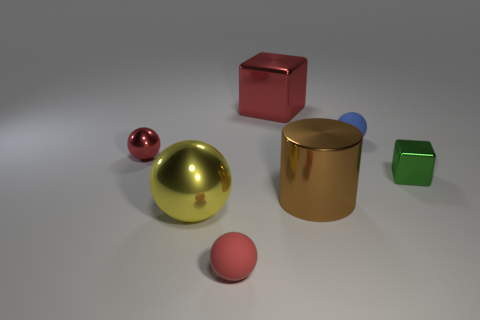Subtract all red shiny spheres. How many spheres are left? 3 Subtract all red blocks. How many red balls are left? 2 Subtract all blue balls. How many balls are left? 3 Add 1 small red things. How many objects exist? 8 Subtract all blue balls. Subtract all gray cylinders. How many balls are left? 3 Subtract all cubes. How many objects are left? 5 Subtract 0 yellow cubes. How many objects are left? 7 Subtract all big brown matte blocks. Subtract all small red metal balls. How many objects are left? 6 Add 3 big red cubes. How many big red cubes are left? 4 Add 5 green metal blocks. How many green metal blocks exist? 6 